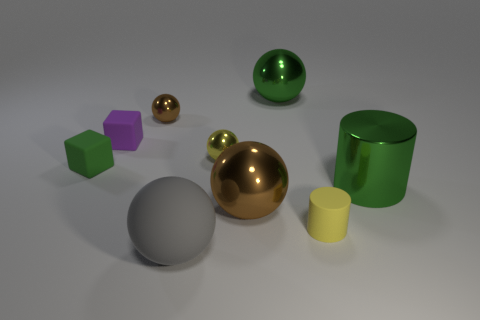Subtract all gray balls. How many balls are left? 4 Subtract all large brown spheres. How many spheres are left? 4 Subtract all cyan balls. Subtract all green cubes. How many balls are left? 5 Subtract all cubes. How many objects are left? 7 Add 9 gray things. How many gray things exist? 10 Subtract 0 cyan balls. How many objects are left? 9 Subtract all green rubber things. Subtract all tiny yellow cylinders. How many objects are left? 7 Add 5 purple objects. How many purple objects are left? 6 